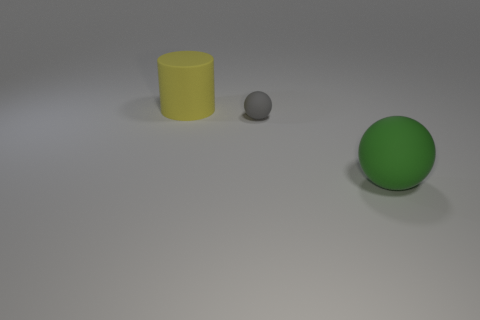Is there a large yellow thing in front of the big thing to the left of the ball that is right of the tiny gray ball?
Offer a terse response. No. Is the number of small purple cylinders less than the number of yellow things?
Provide a succinct answer. Yes. There is a big rubber thing that is left of the small thing; is it the same shape as the gray matte thing?
Offer a terse response. No. Are any large rubber cubes visible?
Your response must be concise. No. There is a big rubber thing in front of the big rubber thing left of the big matte object that is to the right of the large yellow matte thing; what color is it?
Your answer should be compact. Green. Are there the same number of gray objects on the left side of the large yellow rubber cylinder and small gray matte balls that are behind the big green matte thing?
Give a very brief answer. No. What shape is the matte object that is the same size as the yellow matte cylinder?
Your answer should be compact. Sphere. There is a big thing behind the green thing; what is its shape?
Ensure brevity in your answer.  Cylinder. What color is the large matte cylinder?
Provide a succinct answer. Yellow. What color is the large cylinder that is made of the same material as the small object?
Offer a very short reply. Yellow. 